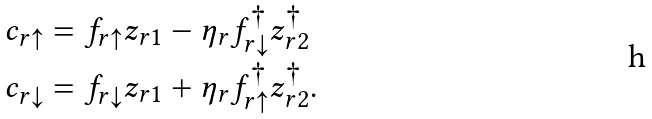<formula> <loc_0><loc_0><loc_500><loc_500>c _ { r \uparrow } & = f _ { r \uparrow } z _ { r 1 } - \eta _ { r } f _ { r \downarrow } ^ { \dagger } z _ { r 2 } ^ { \dagger } \\ c _ { r \downarrow } & = f _ { r \downarrow } z _ { r 1 } + \eta _ { r } f _ { r \uparrow } ^ { \dagger } z _ { r 2 } ^ { \dagger } .</formula> 